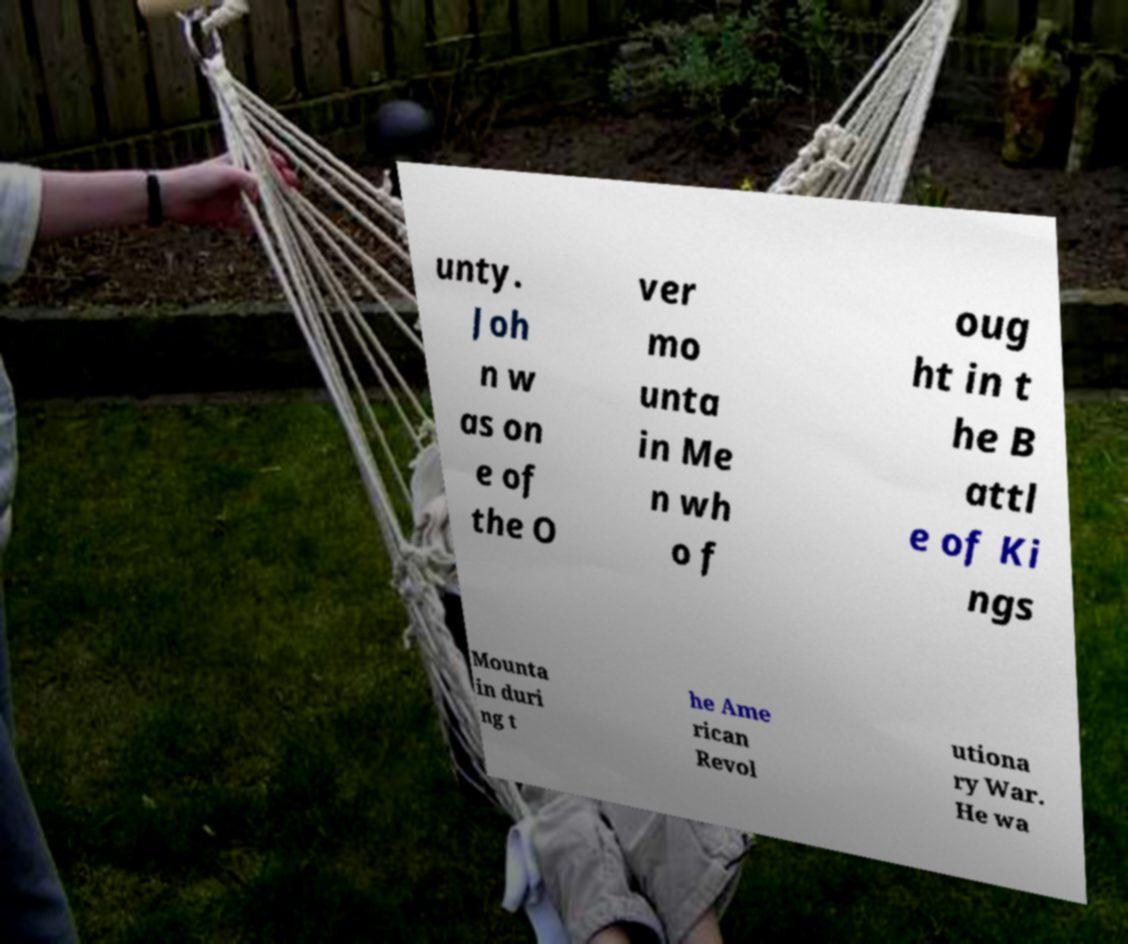Can you read and provide the text displayed in the image?This photo seems to have some interesting text. Can you extract and type it out for me? unty. Joh n w as on e of the O ver mo unta in Me n wh o f oug ht in t he B attl e of Ki ngs Mounta in duri ng t he Ame rican Revol utiona ry War. He wa 